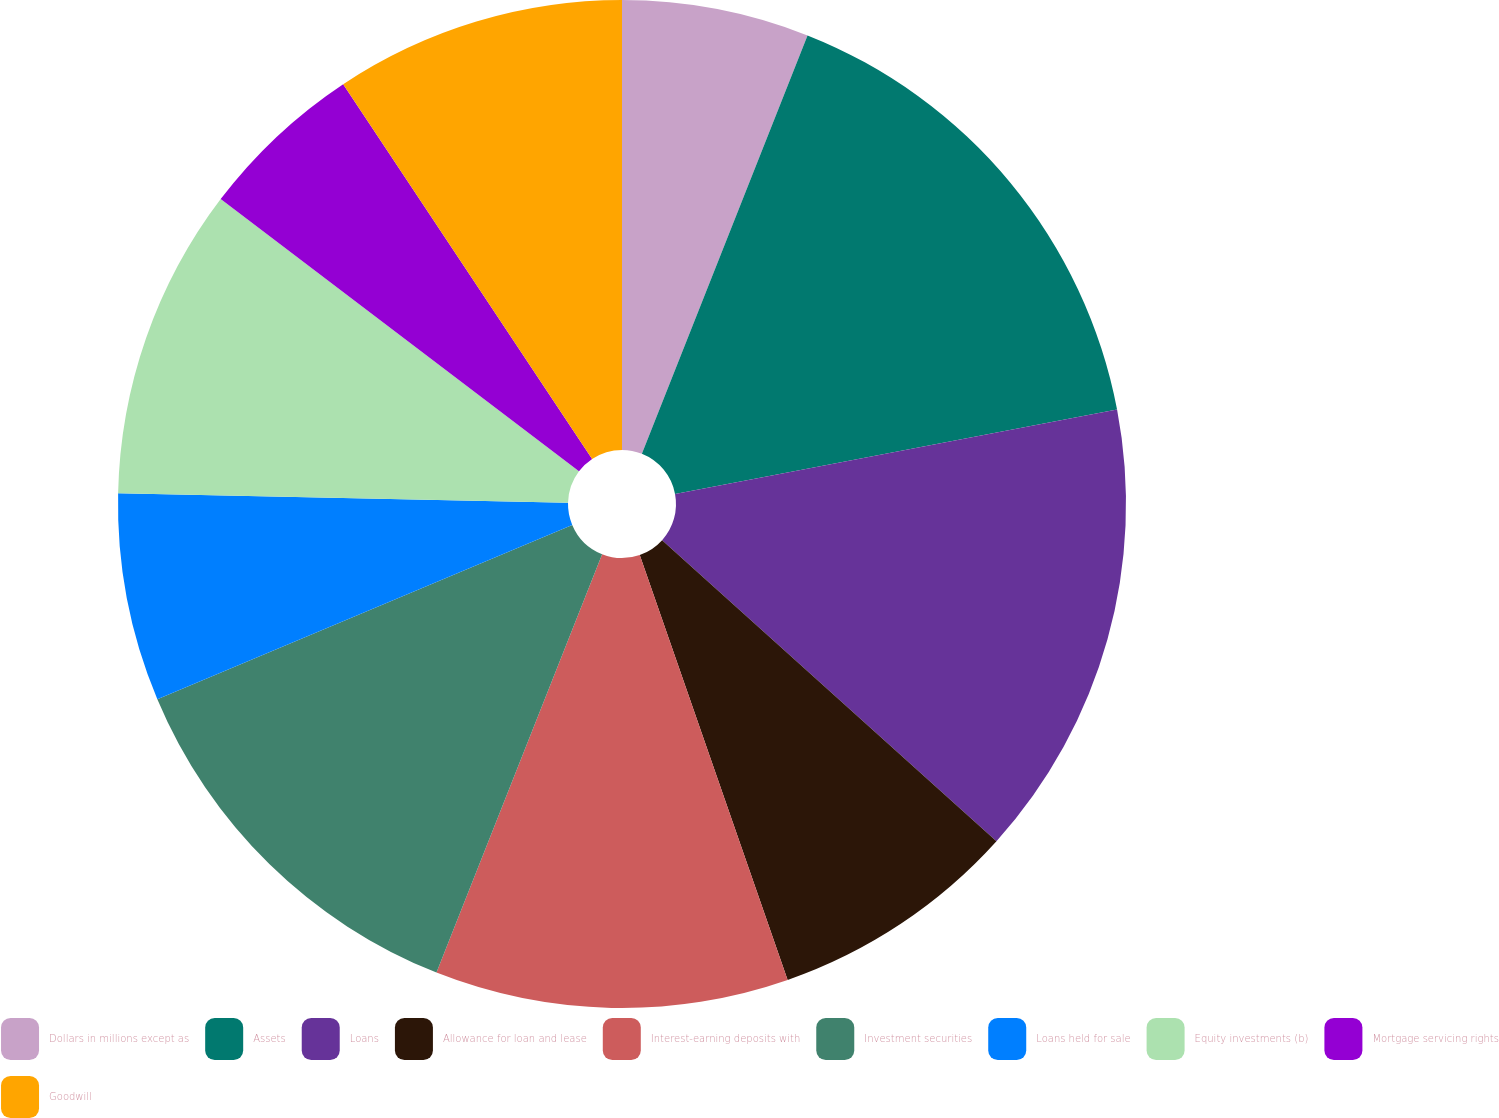Convert chart to OTSL. <chart><loc_0><loc_0><loc_500><loc_500><pie_chart><fcel>Dollars in millions except as<fcel>Assets<fcel>Loans<fcel>Allowance for loan and lease<fcel>Interest-earning deposits with<fcel>Investment securities<fcel>Loans held for sale<fcel>Equity investments (b)<fcel>Mortgage servicing rights<fcel>Goodwill<nl><fcel>6.0%<fcel>16.0%<fcel>14.67%<fcel>8.0%<fcel>11.33%<fcel>12.67%<fcel>6.67%<fcel>10.0%<fcel>5.33%<fcel>9.33%<nl></chart> 